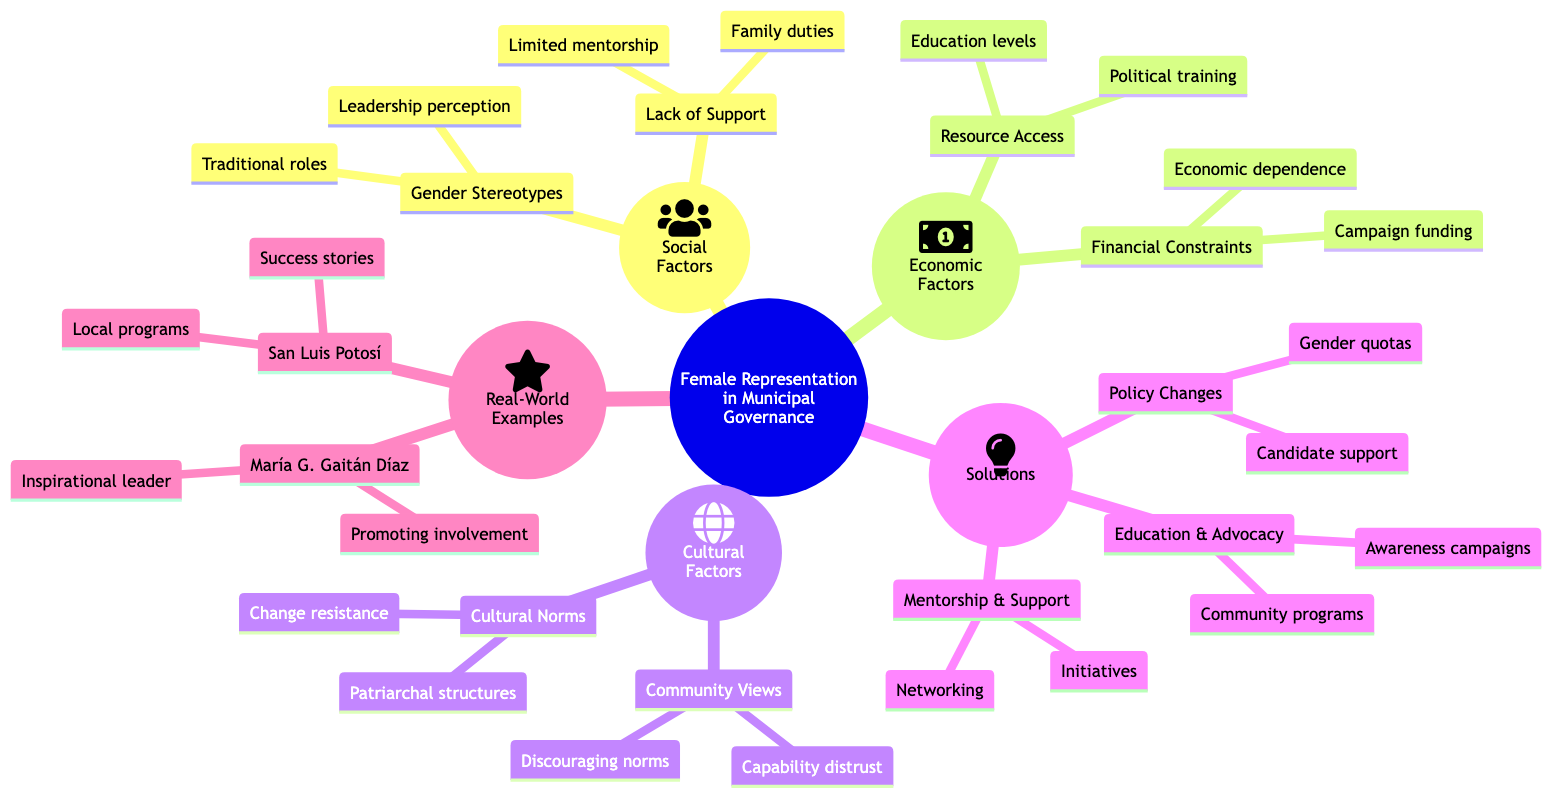What are the main categories impacting female representation? The diagram lists three main categories under "Barriers and Solutions to Increasing Female Representation in Municipal Governance": Social Factors, Economic Factors, and Cultural Factors.
Answer: Social Factors, Economic Factors, Cultural Factors What two types of solutions are proposed? The solutions include three categories: Policy Changes, Education and Advocacy, and Mentorship and Support. The question specifies for two types, which could be any of the pairs like Policy Changes and Education and Advocacy.
Answer: Policy Changes, Education and Advocacy How many different elements are listed under Social Factors? There are two elements under Social Factors: Gender Stereotypes and Lack of Support Networks.
Answer: 2 What is a challenge listed under Financial Constraints? The diagram notes that Campaign funding challenges and Economic dependence on male relatives are part of Financial Constraints. Hence, Campaign funding challenges directly answers the question.
Answer: Campaign funding challenges Which cultural factor relates to societal structures? The diagram specifies that Cultural Norms address Patriarchal societal structures, linking cultural factors to societal structures.
Answer: Patriarchal structures What solution focuses on community education? The solution detailed under Education and Advocacy addresses Awareness campaigns and Educational programs for women and communities. Therefore, Awareness campaigns specifically focus on community education.
Answer: Awareness campaigns Who is mentioned as a key example in promoting women's political involvement? The diagram highlights María Graciela Gaitán Díaz as a significant figure in promoting women's political involvement, providing an exemplary role model.
Answer: María Graciela Gaitán Díaz What type of initiatives can support women in governance? The diagram suggests Mentorship and Support as a type of initiative that could include Mentorship initiatives and Networking opportunities, which directly addresses support in governance.
Answer: Mentorship initiatives How can community views impact female representation? Community Perceptions including Distrust in women's capabilities and Norms discouraging women's political involvement may lessen female representation efficacy, demonstrating the impact of societal perceptions.
Answer: Distrust in women's capabilities 